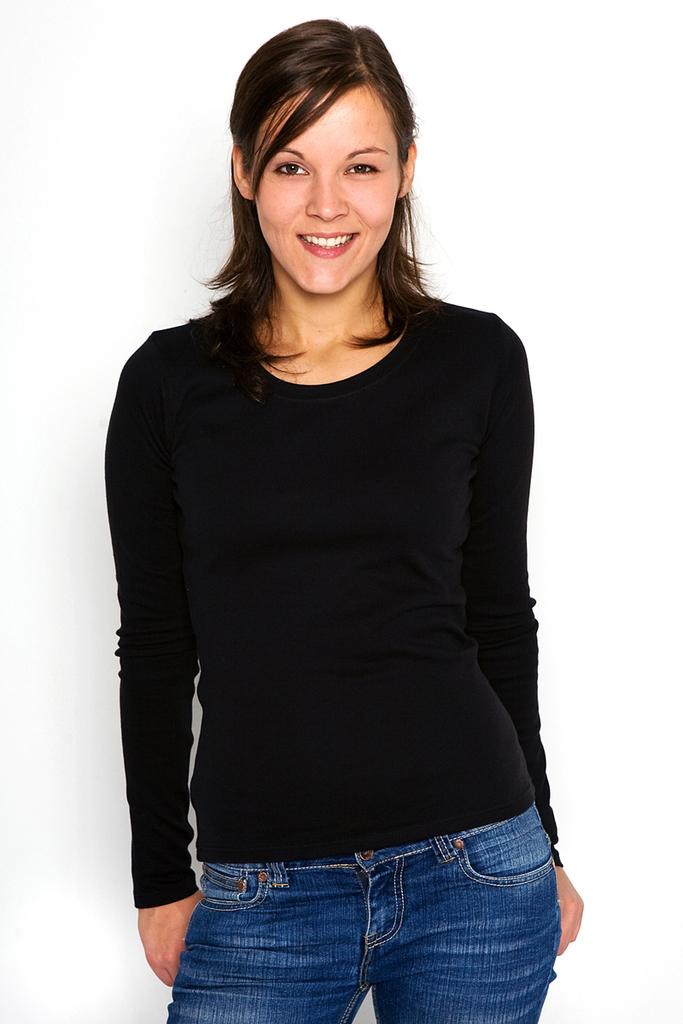What is the main subject of the image? There is a woman standing in the image. Where is the woman positioned in the image? The woman is in the center of the image. What type of stone is the woman holding in the image? There is no stone present in the image; the woman is not holding anything. 